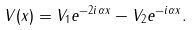Convert formula to latex. <formula><loc_0><loc_0><loc_500><loc_500>V ( x ) = V _ { 1 } e ^ { - 2 i \alpha x } - V _ { 2 } e ^ { - i \alpha x } .</formula> 